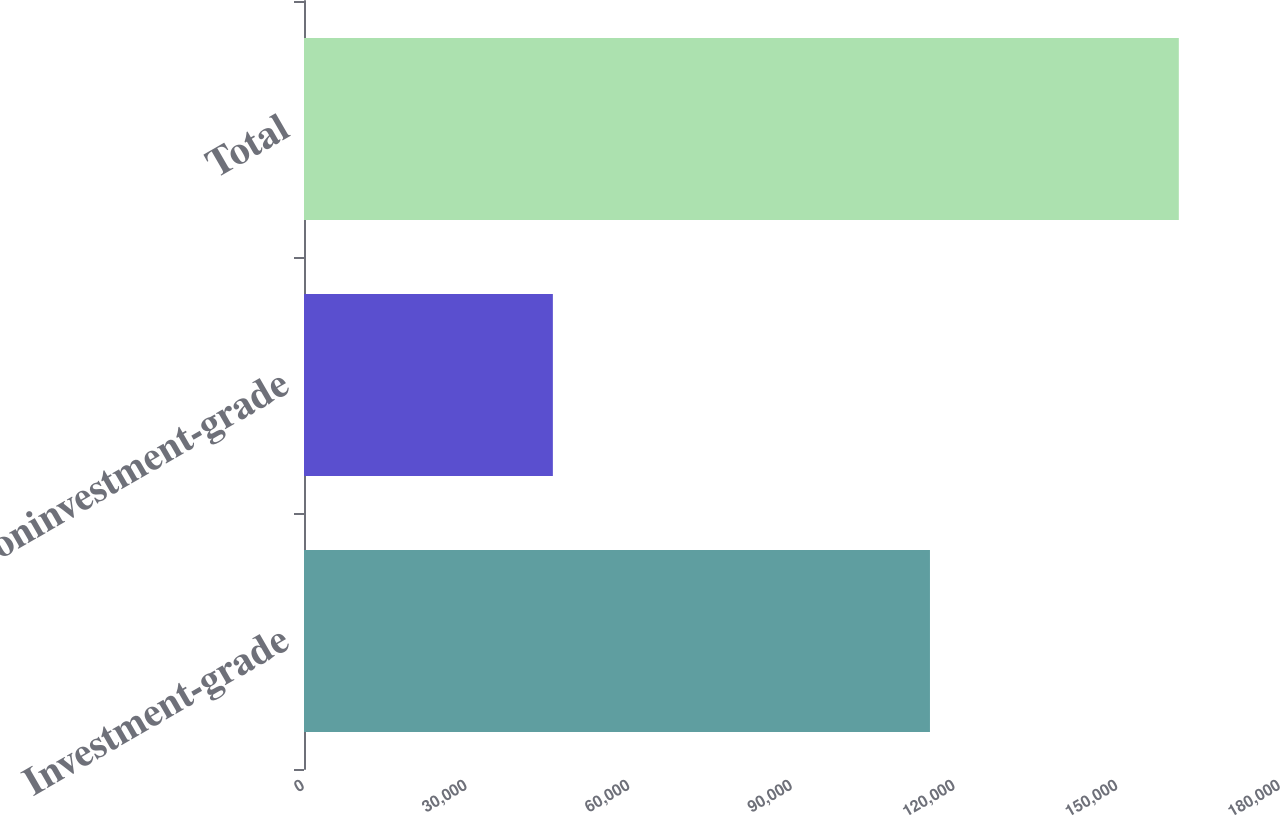Convert chart. <chart><loc_0><loc_0><loc_500><loc_500><bar_chart><fcel>Investment-grade<fcel>Noninvestment-grade<fcel>Total<nl><fcel>115443<fcel>45897<fcel>161340<nl></chart> 